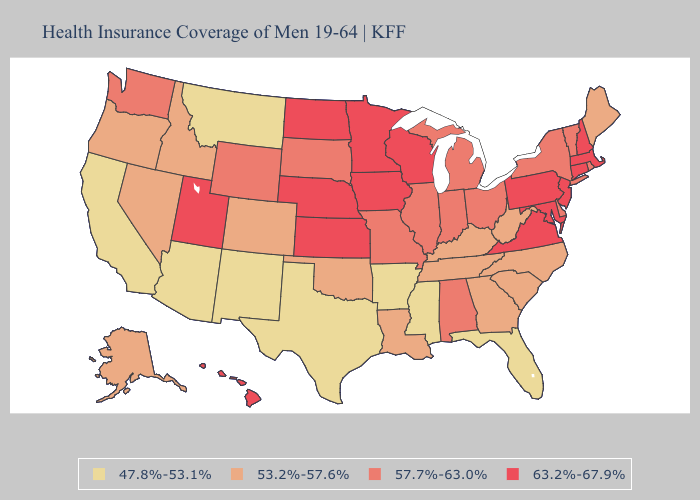Among the states that border California , does Arizona have the highest value?
Concise answer only. No. Does Missouri have the lowest value in the USA?
Write a very short answer. No. What is the lowest value in the USA?
Give a very brief answer. 47.8%-53.1%. Which states hav the highest value in the Northeast?
Quick response, please. Connecticut, Massachusetts, New Hampshire, New Jersey, Pennsylvania. Which states have the lowest value in the South?
Short answer required. Arkansas, Florida, Mississippi, Texas. Does Vermont have the lowest value in the USA?
Write a very short answer. No. What is the value of Indiana?
Be succinct. 57.7%-63.0%. Does Arkansas have the lowest value in the South?
Write a very short answer. Yes. Does Vermont have a lower value than Minnesota?
Quick response, please. Yes. Which states have the highest value in the USA?
Keep it brief. Connecticut, Hawaii, Iowa, Kansas, Maryland, Massachusetts, Minnesota, Nebraska, New Hampshire, New Jersey, North Dakota, Pennsylvania, Utah, Virginia, Wisconsin. How many symbols are there in the legend?
Short answer required. 4. What is the value of Michigan?
Give a very brief answer. 57.7%-63.0%. Name the states that have a value in the range 57.7%-63.0%?
Answer briefly. Alabama, Delaware, Illinois, Indiana, Michigan, Missouri, New York, Ohio, Rhode Island, South Dakota, Vermont, Washington, Wyoming. Does the first symbol in the legend represent the smallest category?
Concise answer only. Yes. 